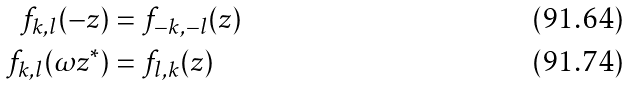<formula> <loc_0><loc_0><loc_500><loc_500>f _ { k , l } ( - z ) & = f _ { - k , - l } ( z ) \\ f _ { k , l } ( \omega z ^ { * } ) & = f _ { l , k } ( z )</formula> 